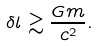Convert formula to latex. <formula><loc_0><loc_0><loc_500><loc_500>\delta l \gtrsim \frac { G m } { c ^ { 2 } } .</formula> 